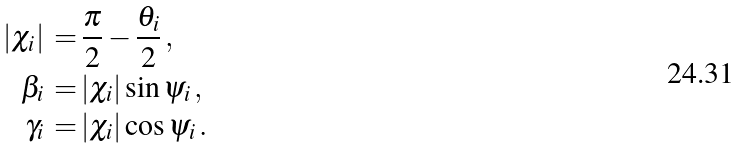Convert formula to latex. <formula><loc_0><loc_0><loc_500><loc_500>| \chi _ { i } | \, = & \, \frac { \pi } { 2 } - \frac { \theta _ { i } } { 2 } \, , \\ \beta _ { i } \, = & \, | \chi _ { i } | \sin { \psi _ { i } } \, , \\ \gamma _ { i } \, = & \, | \chi _ { i } | \cos { \psi _ { i } } \, .</formula> 